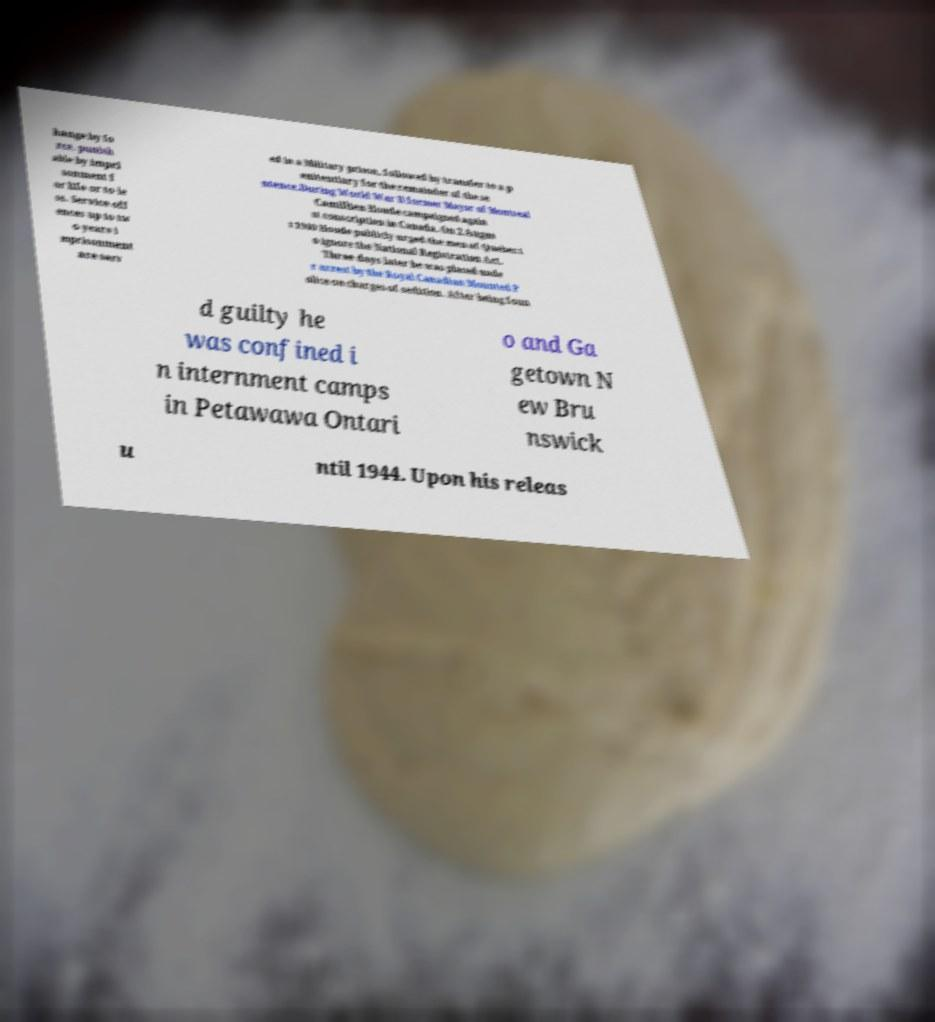I need the written content from this picture converted into text. Can you do that? hange by fo rce, punish able by impri sonment f or life or to le ss. Service off ences up to tw o years i mprisonment are serv ed in a Military prison, followed by transfer to a p enitentiary for the remainder of the se ntence.During World War II former Mayor of Montreal Camillien Houde campaigned again st conscription in Canada. On 2 Augus t 1940 Houde publicly urged the men of Quebec t o ignore the National Registration Act. Three days later he was placed unde r arrest by the Royal Canadian Mounted P olice on charges of sedition. After being foun d guilty he was confined i n internment camps in Petawawa Ontari o and Ga getown N ew Bru nswick u ntil 1944. Upon his releas 